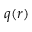<formula> <loc_0><loc_0><loc_500><loc_500>q ( r )</formula> 